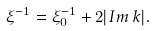<formula> <loc_0><loc_0><loc_500><loc_500>\xi ^ { - 1 } = \xi _ { 0 } ^ { - 1 } + 2 | I m \, k | .</formula> 